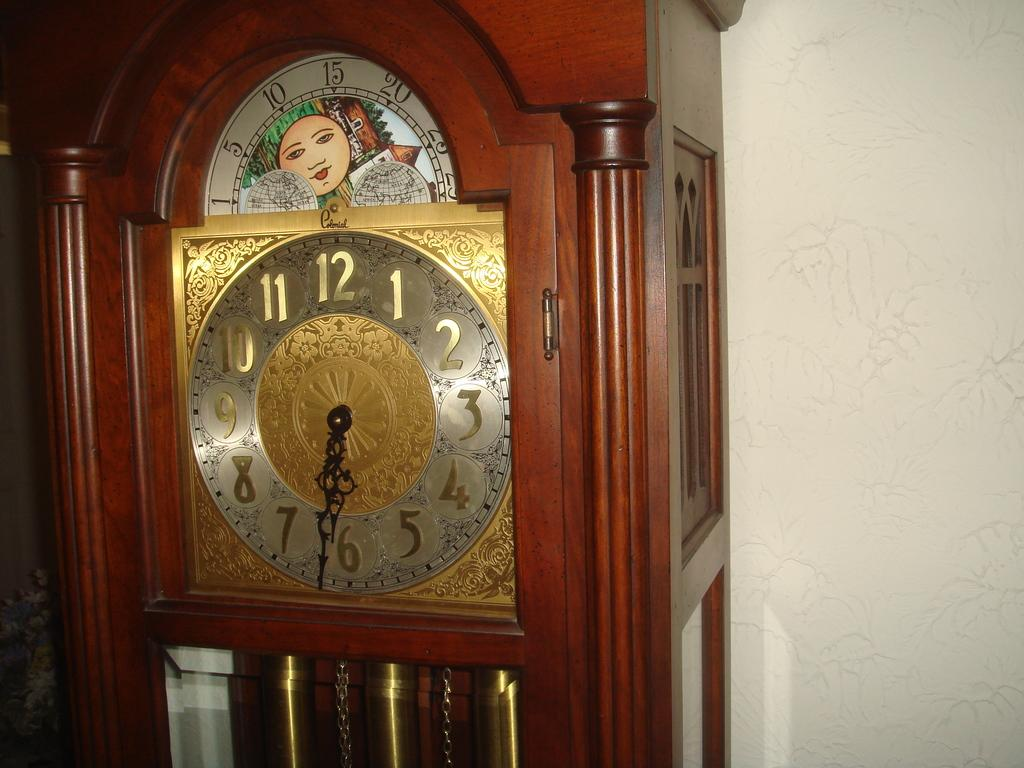<image>
Create a compact narrative representing the image presented. A large, wooden grandfather clock with the time displayed of 6:32. 